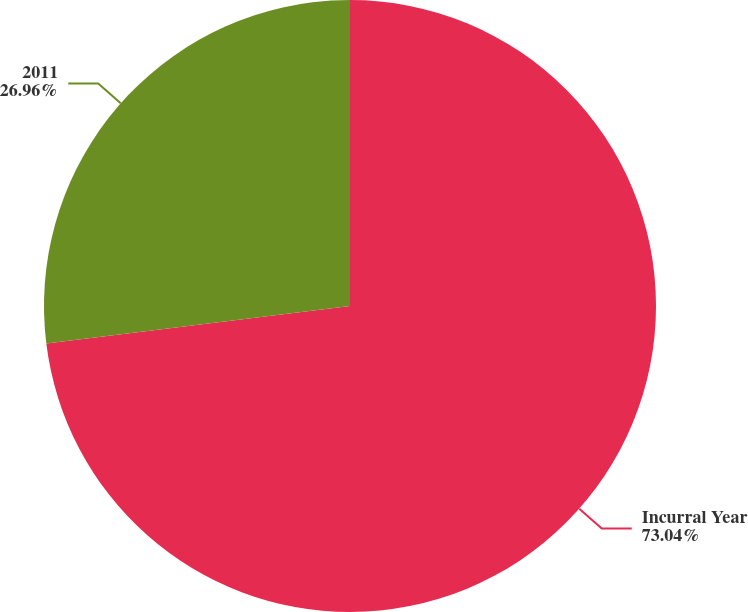Convert chart to OTSL. <chart><loc_0><loc_0><loc_500><loc_500><pie_chart><fcel>Incurral Year<fcel>2011<nl><fcel>73.04%<fcel>26.96%<nl></chart> 